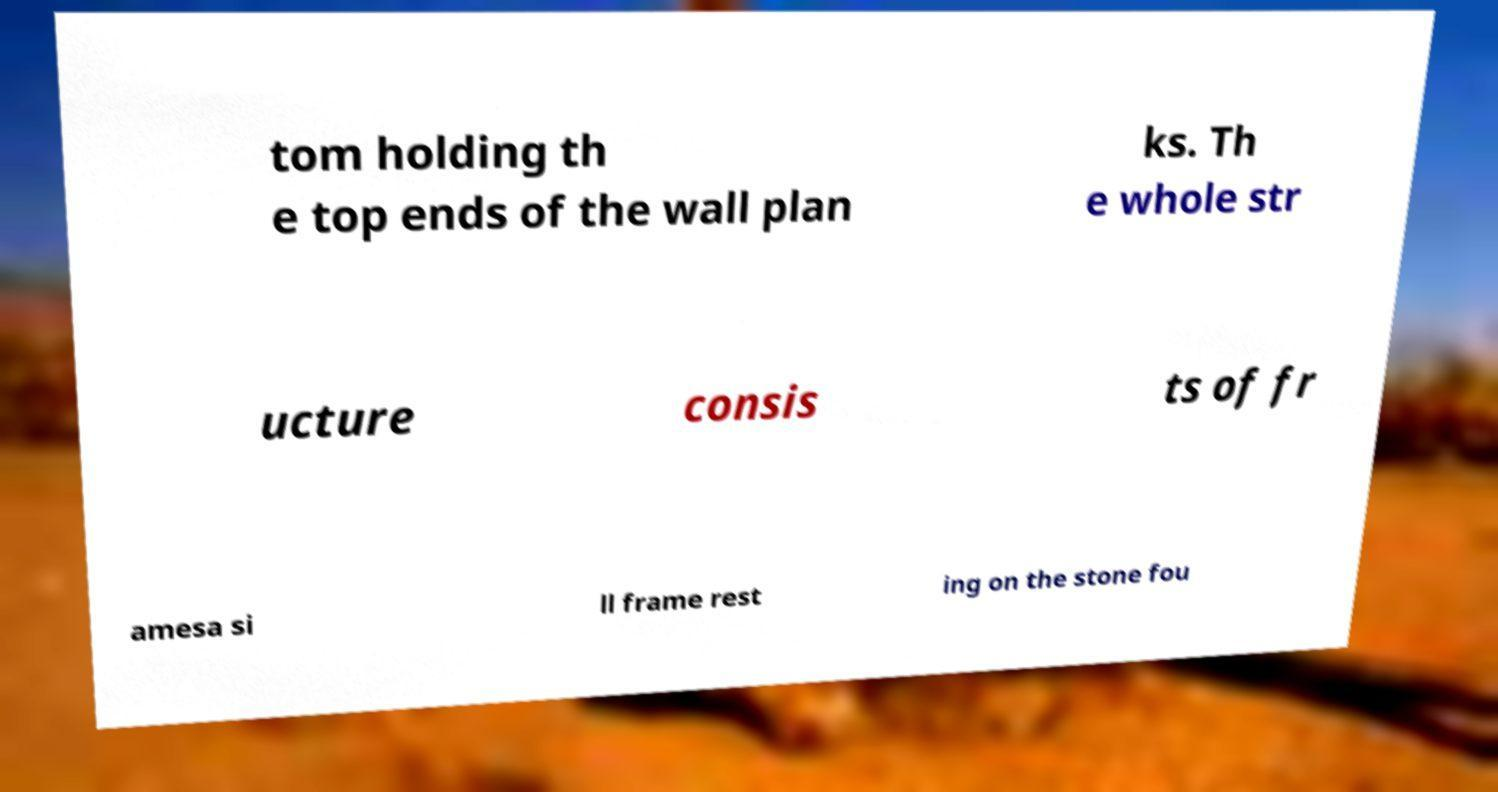What messages or text are displayed in this image? I need them in a readable, typed format. tom holding th e top ends of the wall plan ks. Th e whole str ucture consis ts of fr amesa si ll frame rest ing on the stone fou 